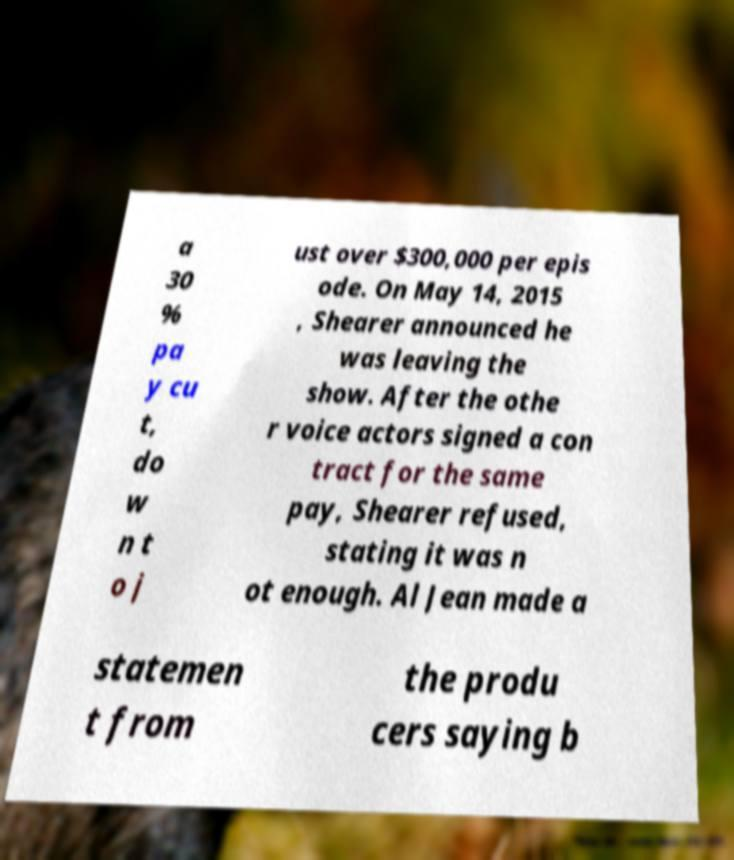I need the written content from this picture converted into text. Can you do that? a 30 % pa y cu t, do w n t o j ust over $300,000 per epis ode. On May 14, 2015 , Shearer announced he was leaving the show. After the othe r voice actors signed a con tract for the same pay, Shearer refused, stating it was n ot enough. Al Jean made a statemen t from the produ cers saying b 